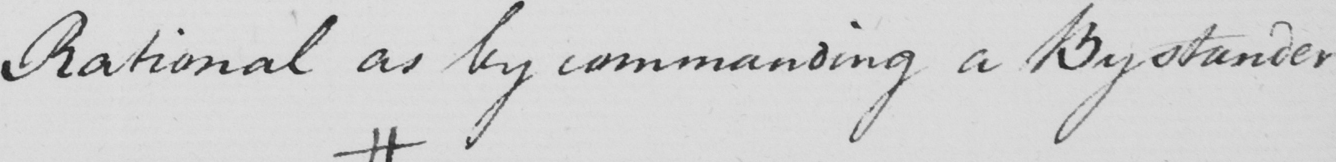What does this handwritten line say? Rational as by commanding a Bystander 